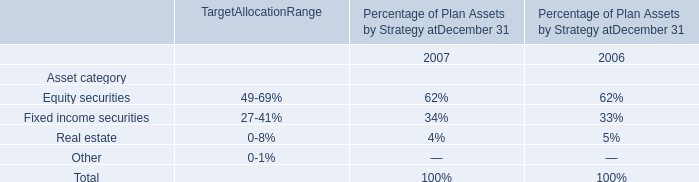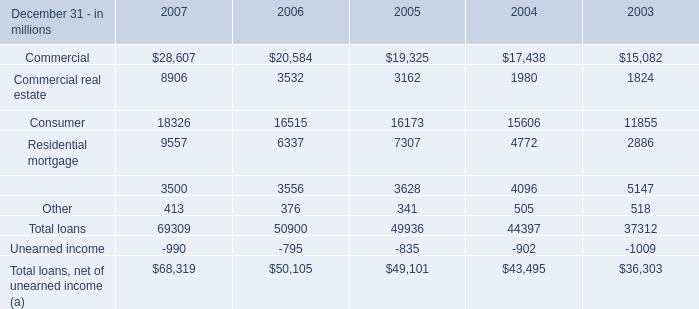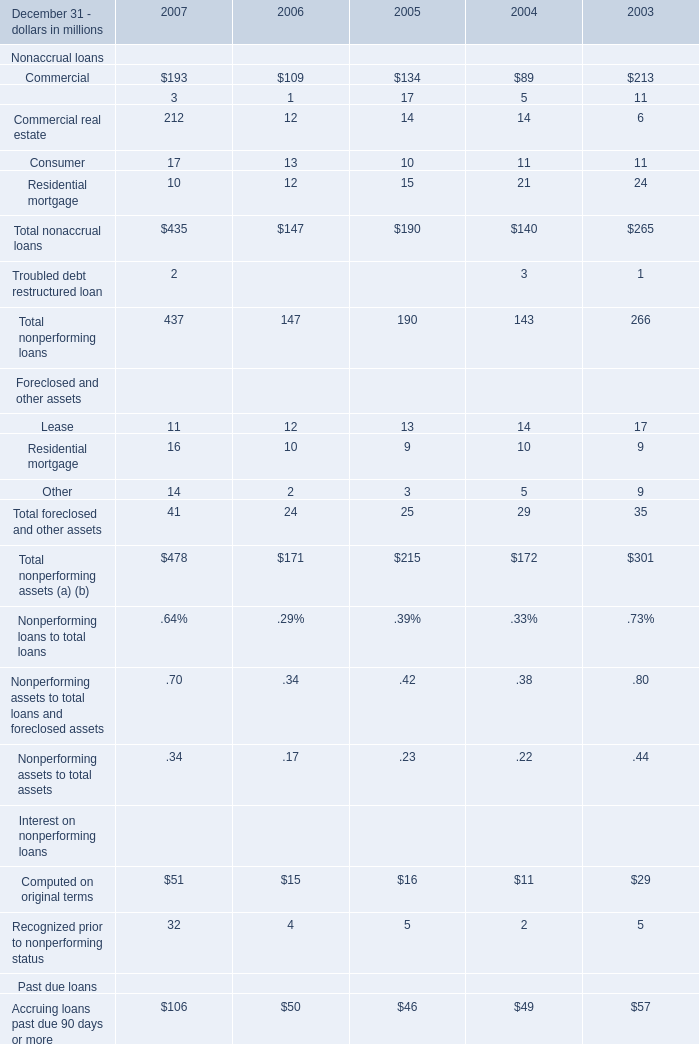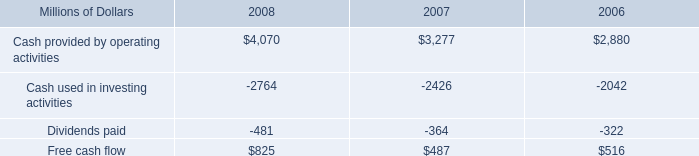Does the value of Nonaccrual loans:Commercial in 2004 greater than that in 2003? 
Answer: no. 